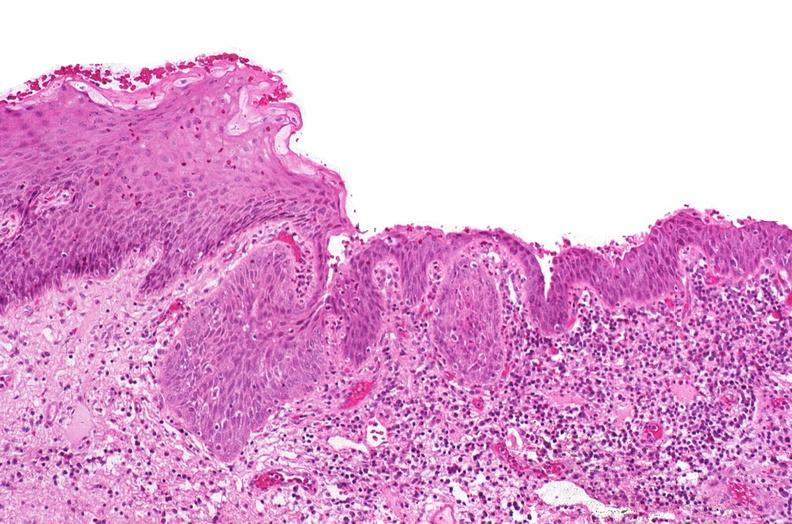where is this?
Answer the question using a single word or phrase. Urinary 